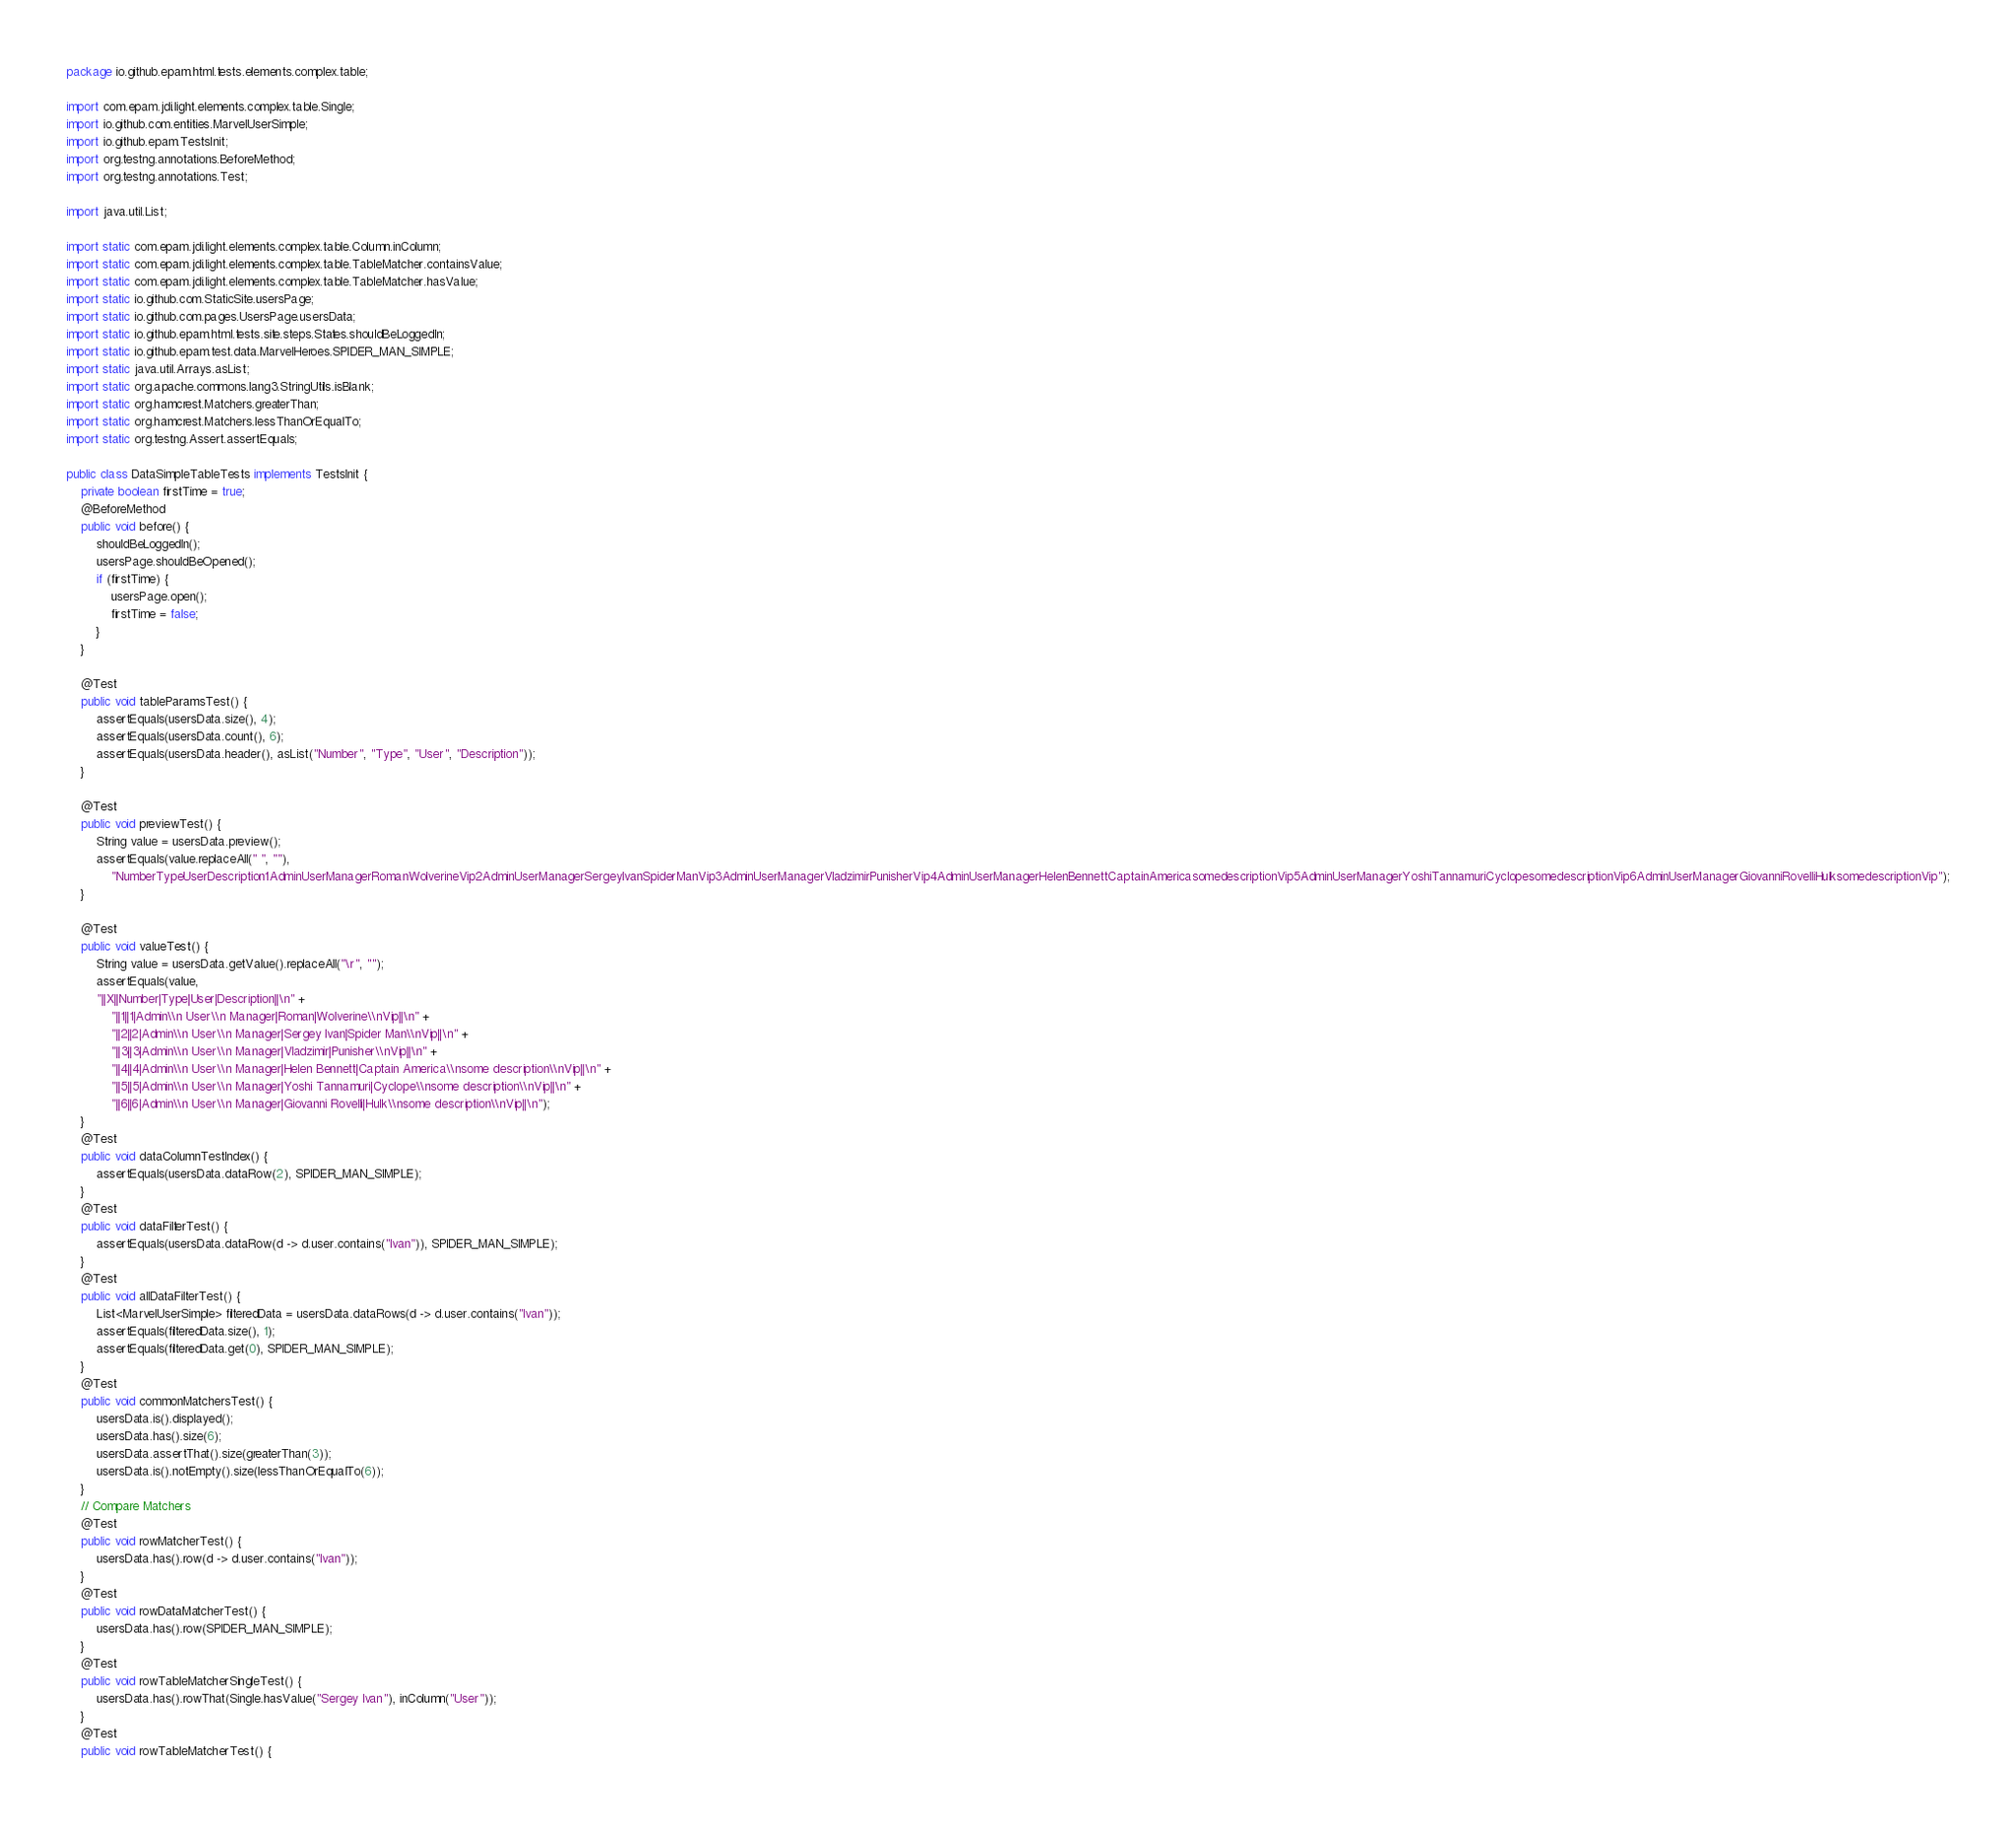<code> <loc_0><loc_0><loc_500><loc_500><_Java_>package io.github.epam.html.tests.elements.complex.table;

import com.epam.jdi.light.elements.complex.table.Single;
import io.github.com.entities.MarvelUserSimple;
import io.github.epam.TestsInit;
import org.testng.annotations.BeforeMethod;
import org.testng.annotations.Test;

import java.util.List;

import static com.epam.jdi.light.elements.complex.table.Column.inColumn;
import static com.epam.jdi.light.elements.complex.table.TableMatcher.containsValue;
import static com.epam.jdi.light.elements.complex.table.TableMatcher.hasValue;
import static io.github.com.StaticSite.usersPage;
import static io.github.com.pages.UsersPage.usersData;
import static io.github.epam.html.tests.site.steps.States.shouldBeLoggedIn;
import static io.github.epam.test.data.MarvelHeroes.SPIDER_MAN_SIMPLE;
import static java.util.Arrays.asList;
import static org.apache.commons.lang3.StringUtils.isBlank;
import static org.hamcrest.Matchers.greaterThan;
import static org.hamcrest.Matchers.lessThanOrEqualTo;
import static org.testng.Assert.assertEquals;

public class DataSimpleTableTests implements TestsInit {
    private boolean firstTime = true;
    @BeforeMethod
    public void before() {
        shouldBeLoggedIn();
        usersPage.shouldBeOpened();
        if (firstTime) {
            usersPage.open();
            firstTime = false;
        }
    }

    @Test
    public void tableParamsTest() {
        assertEquals(usersData.size(), 4);
        assertEquals(usersData.count(), 6);
        assertEquals(usersData.header(), asList("Number", "Type", "User", "Description"));
    }

    @Test
    public void previewTest() {
        String value = usersData.preview();
        assertEquals(value.replaceAll(" ", ""),
            "NumberTypeUserDescription1AdminUserManagerRomanWolverineVip2AdminUserManagerSergeyIvanSpiderManVip3AdminUserManagerVladzimirPunisherVip4AdminUserManagerHelenBennettCaptainAmericasomedescriptionVip5AdminUserManagerYoshiTannamuriCyclopesomedescriptionVip6AdminUserManagerGiovanniRovelliHulksomedescriptionVip");
    }

    @Test
    public void valueTest() {
        String value = usersData.getValue().replaceAll("\r", "");
        assertEquals(value,
        "||X||Number|Type|User|Description||\n" +
            "||1||1|Admin\\n User\\n Manager|Roman|Wolverine\\nVip||\n" +
            "||2||2|Admin\\n User\\n Manager|Sergey Ivan|Spider Man\\nVip||\n" +
            "||3||3|Admin\\n User\\n Manager|Vladzimir|Punisher\\nVip||\n" +
            "||4||4|Admin\\n User\\n Manager|Helen Bennett|Captain America\\nsome description\\nVip||\n" +
            "||5||5|Admin\\n User\\n Manager|Yoshi Tannamuri|Cyclope\\nsome description\\nVip||\n" +
            "||6||6|Admin\\n User\\n Manager|Giovanni Rovelli|Hulk\\nsome description\\nVip||\n");
    }
    @Test
    public void dataColumnTestIndex() {
        assertEquals(usersData.dataRow(2), SPIDER_MAN_SIMPLE);
    }
    @Test
    public void dataFilterTest() {
        assertEquals(usersData.dataRow(d -> d.user.contains("Ivan")), SPIDER_MAN_SIMPLE);
    }
    @Test
    public void allDataFilterTest() {
        List<MarvelUserSimple> filteredData = usersData.dataRows(d -> d.user.contains("Ivan"));
        assertEquals(filteredData.size(), 1);
        assertEquals(filteredData.get(0), SPIDER_MAN_SIMPLE);
    }
    @Test
    public void commonMatchersTest() {
        usersData.is().displayed();
        usersData.has().size(6);
        usersData.assertThat().size(greaterThan(3));
        usersData.is().notEmpty().size(lessThanOrEqualTo(6));
    }
    // Compare Matchers
    @Test
    public void rowMatcherTest() {
        usersData.has().row(d -> d.user.contains("Ivan"));
    }
    @Test
    public void rowDataMatcherTest() {
        usersData.has().row(SPIDER_MAN_SIMPLE);
    }
    @Test
    public void rowTableMatcherSingleTest() {
        usersData.has().rowThat(Single.hasValue("Sergey Ivan"), inColumn("User"));
    }
    @Test
    public void rowTableMatcherTest() {</code> 